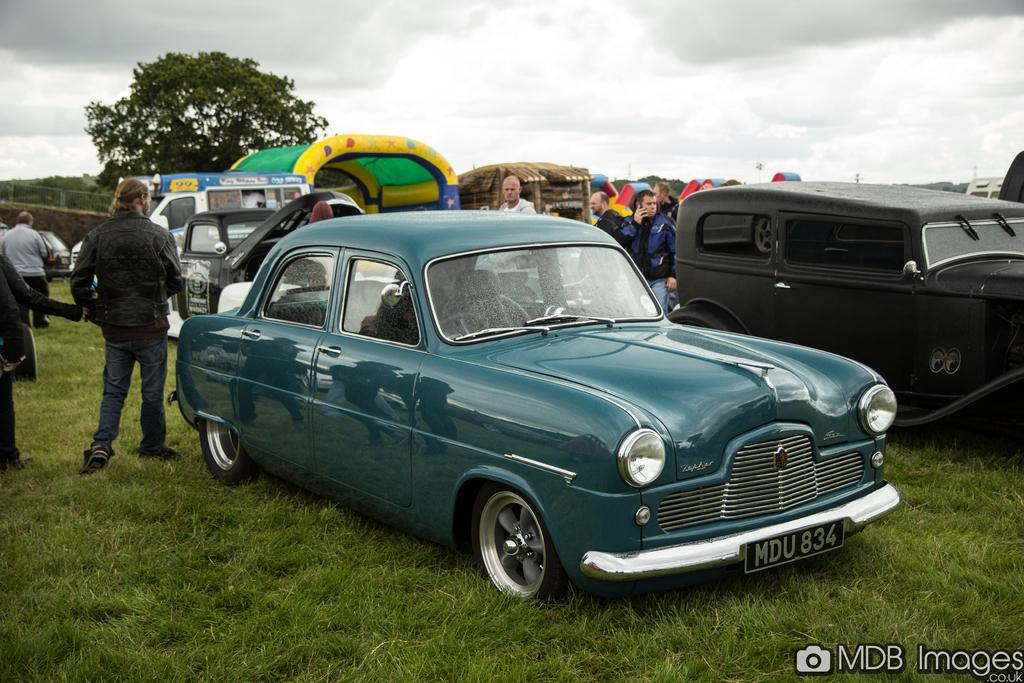<image>
Render a clear and concise summary of the photo. A picture of a car show by MDB Images. 